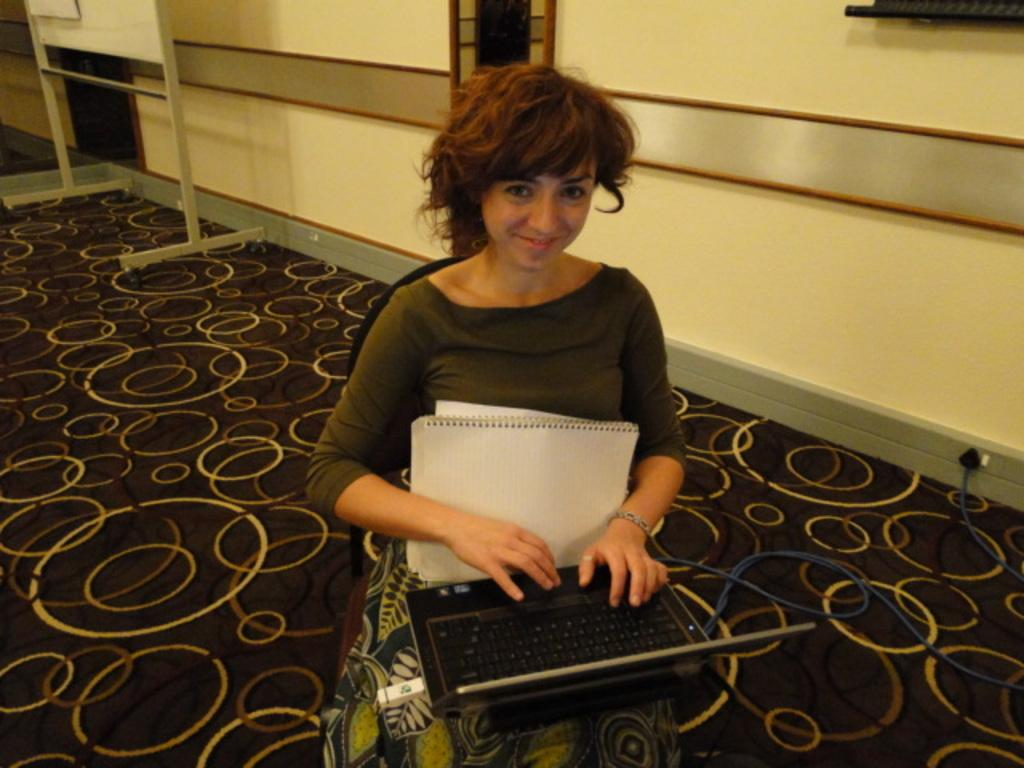What is the woman doing in the image? The woman is sitting on a chair and working on a laptop. What else can be seen near the woman? There is a book near the woman. What is the background of the image? There is a wall in the image, and a board is also visible. What type of pancake is the woman eating in the image? There is no pancake present in the image; the woman is working on a laptop and there is a book near her. 